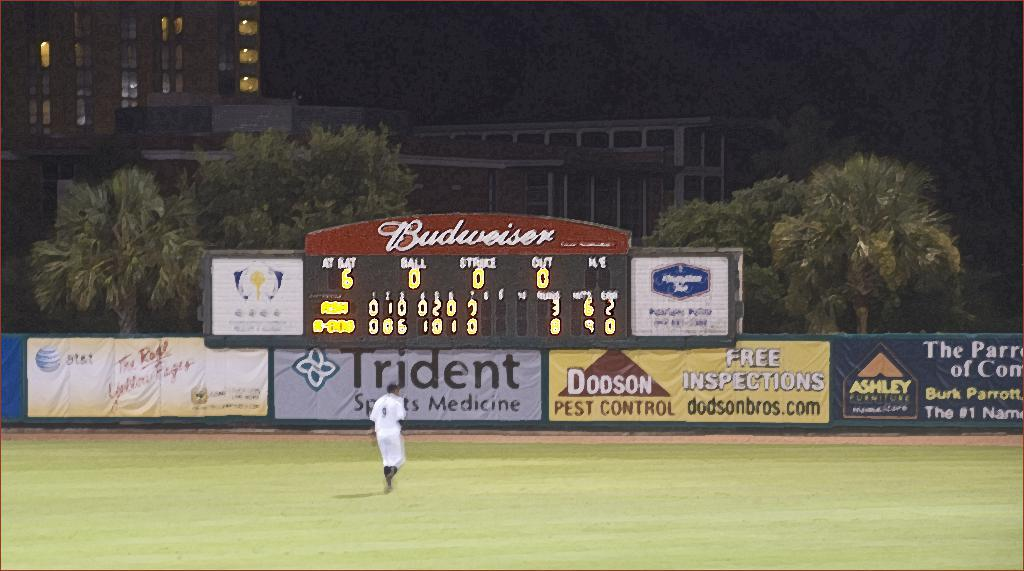<image>
Give a short and clear explanation of the subsequent image. A baseball diamond with a large ad for Budweiser above the scoreboard. 